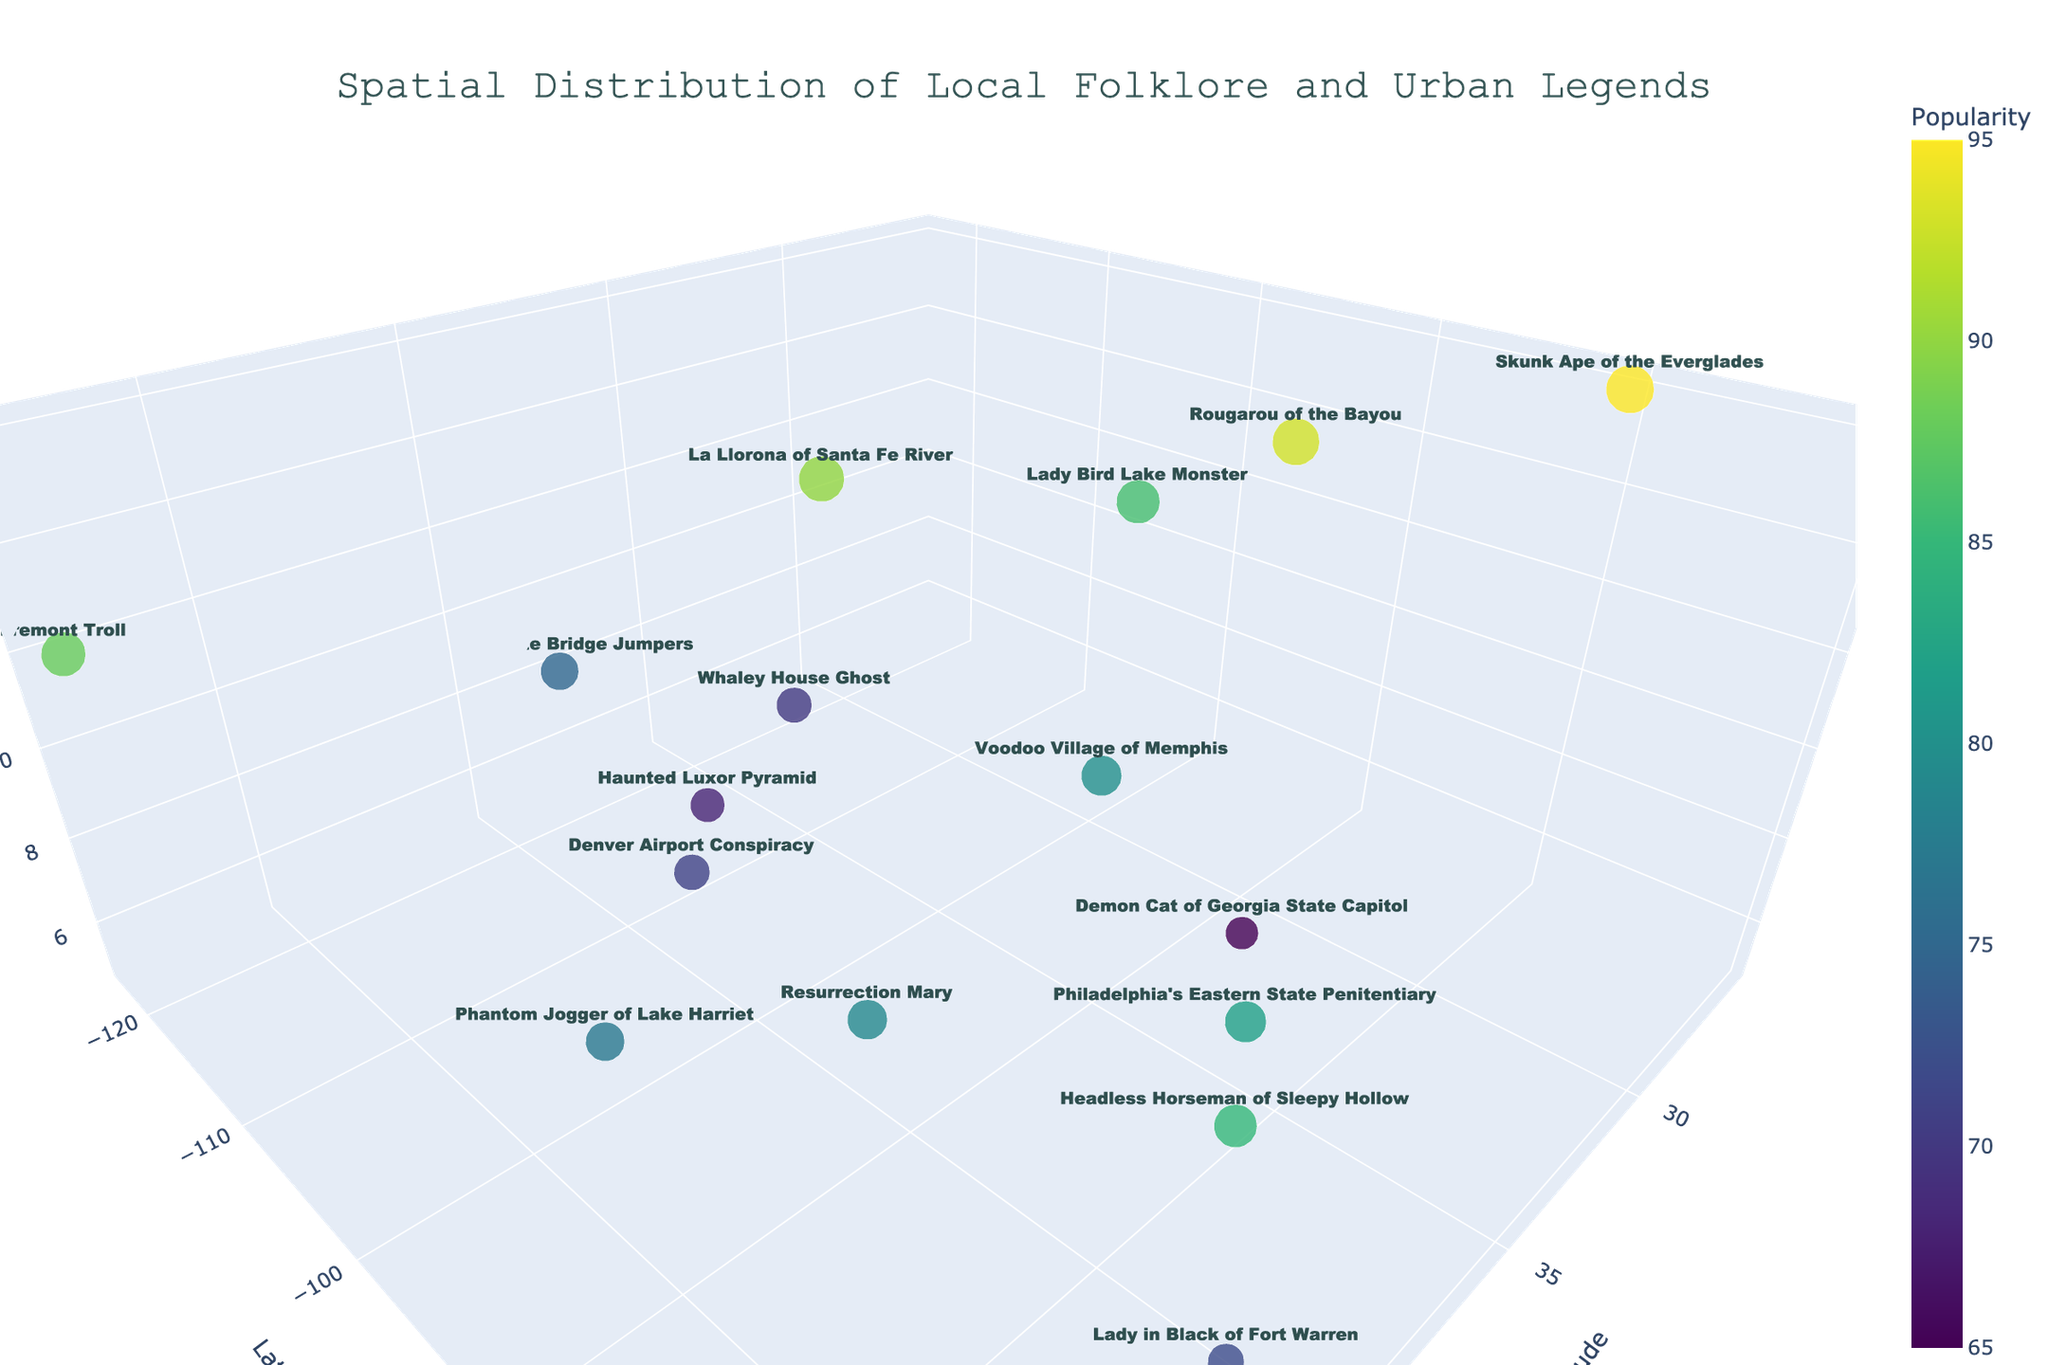what is the title of the 3D volume plot? The title is usually located at the top of the plot. In this case, it reads "Spatial Distribution of Local Folklore and Urban Legends".
Answer: Spatial Distribution of Local Folklore and Urban Legends Which folklore or urban legend has the highest popularity value? Look at the color and size of the markers, which indicate popularity. The largest and most intense color corresponds to the highest popularity. The Skunk Ape of the Everglades has the highest popularity value, displayed as 95 on the hover text.
Answer: Skunk Ape of the Everglades What do the axes represent in the plot? The x, y, and z axes are labeled with textual information and their titles are visible on the plot. The x-axis represents Longitude, the y-axis represents Latitude, and the z-axis represents Legend Intensity.
Answer: Longitude, Latitude, Legend Intensity How many legends have a popularity value above 80? Look at the hover texts for each marker to count how many show a popularity value above 80. Examining the color bar can also help identify markers with high popularity. Five urban legends have a popularity value above 80.
Answer: 5 Which city is associated with the legend of the "Lady in Black of Fort Warren"? On the figure, locate the legend. The associated text information or hover text for the "Lady in Black of Fort Warren" marker indicates it belongs to Boston, denoted by the coordinates (42.3601, -71.0589).
Answer: Boston How does the popularity of "Resurrection Mary" compare to that of "Demon Cat of Georgia State Capitol"? Use the hover texts to compare the popularity values of the two legends. "Resurrection Mary" has a popularity of 79, and "Demon Cat of Georgia State Capitol" has a popularity of 65, making "Resurrection Mary" more popular.
Answer: Resurrection Mary is more popular What is the most intense legend by location in Texas? Identify the markers located in Texas by looking at their coordinates and hover texts. The legend with the greatest height on the z-axis (Legend Intensity) in Texas is "Lady Bird Lake Monster".
Answer: Lady Bird Lake Monster Which legend is located at approximately 30° latitude, -90° longitude? Examine the markers near the given coordinates and check the hover text. The legend at these coordinates is the "Rougarou of the Bayou".
Answer: Rougarou of the Bayou Identify the latitude and longitude values for the "Fremont Troll". Find the "Fremont Troll" in the marker text and hover text. The coordinates provided are approximately 47.6062 latitude and -122.3321 longitude.
Answer: 47.6062, -122.3321 What legend has a popularity value closest to the average popularity of all legends in the plot? Calculate the average popularity by summing the popularity values and dividing by the number of legends. Identify which legend's popularity value is closest to this average by comparing each value. The total sum of popularity is 1216, and the number of legends is 16, so the average is 76. The "Golden Gate Bridge Jumpers" with a popularity of 75 is closest to the average.
Answer: Golden Gate Bridge Jumpers 